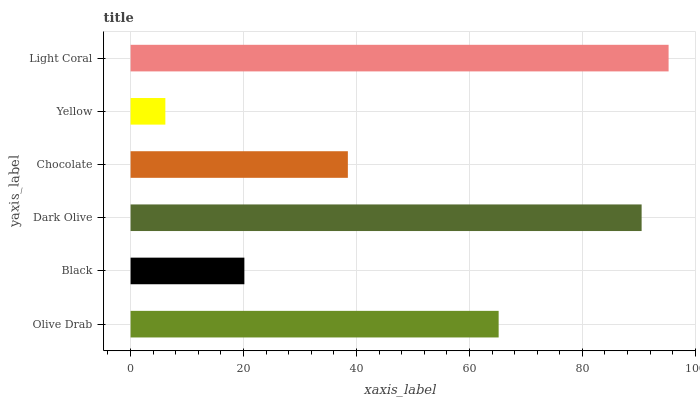Is Yellow the minimum?
Answer yes or no. Yes. Is Light Coral the maximum?
Answer yes or no. Yes. Is Black the minimum?
Answer yes or no. No. Is Black the maximum?
Answer yes or no. No. Is Olive Drab greater than Black?
Answer yes or no. Yes. Is Black less than Olive Drab?
Answer yes or no. Yes. Is Black greater than Olive Drab?
Answer yes or no. No. Is Olive Drab less than Black?
Answer yes or no. No. Is Olive Drab the high median?
Answer yes or no. Yes. Is Chocolate the low median?
Answer yes or no. Yes. Is Chocolate the high median?
Answer yes or no. No. Is Olive Drab the low median?
Answer yes or no. No. 